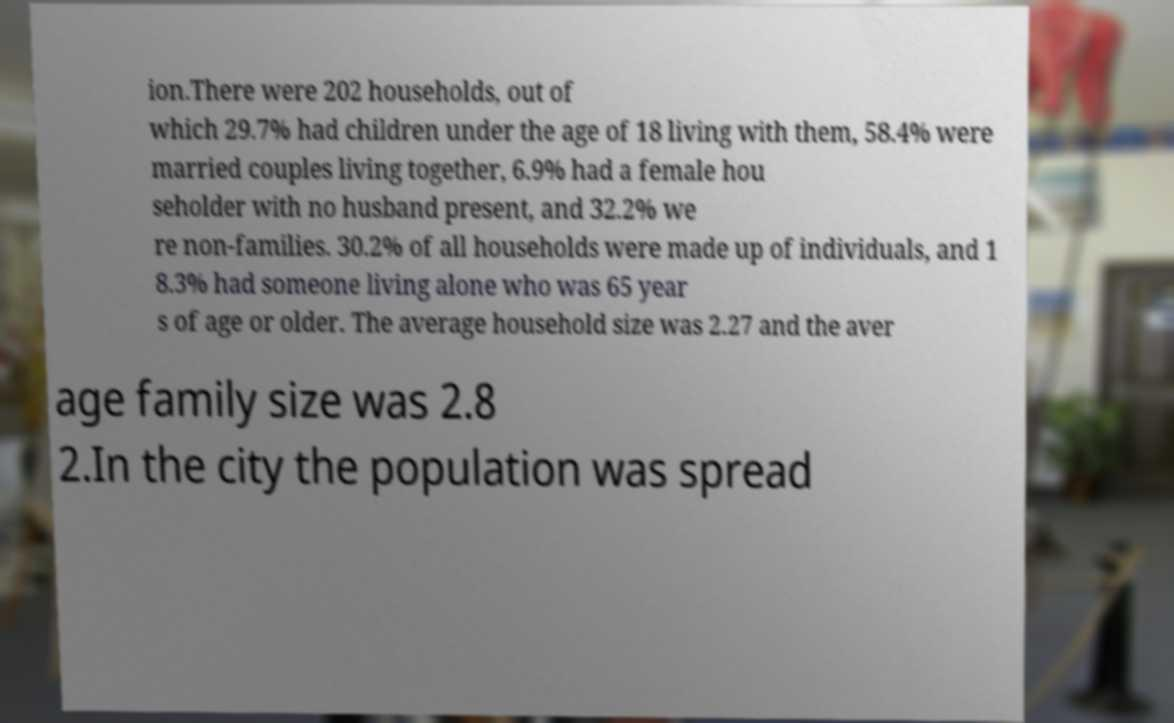Could you assist in decoding the text presented in this image and type it out clearly? ion.There were 202 households, out of which 29.7% had children under the age of 18 living with them, 58.4% were married couples living together, 6.9% had a female hou seholder with no husband present, and 32.2% we re non-families. 30.2% of all households were made up of individuals, and 1 8.3% had someone living alone who was 65 year s of age or older. The average household size was 2.27 and the aver age family size was 2.8 2.In the city the population was spread 